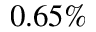<formula> <loc_0><loc_0><loc_500><loc_500>0 . 6 5 \%</formula> 